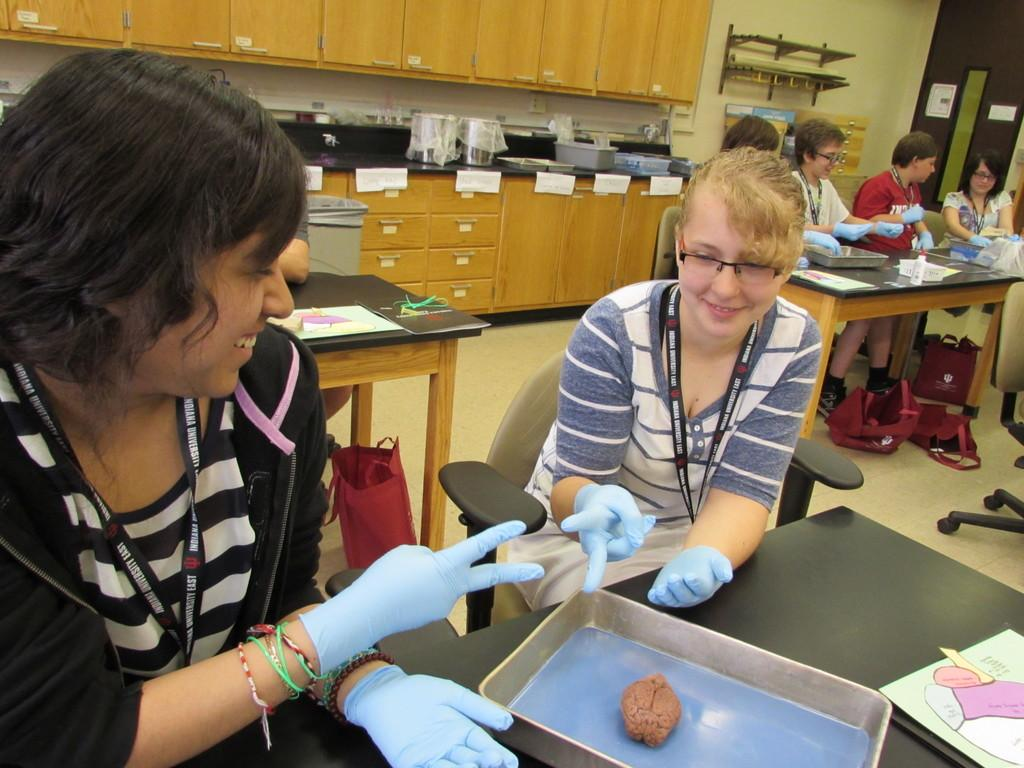How many women are in the image? There are two women in the image. What are the women doing in the image? The women are sitting in the image. What is in front of the women? There is a table in front of the women. Can you describe the people in the background of the image? There is another group of people in the background of the image, and they are also sitting. What type of powder is being used by the son in the image? There is no son present in the image, and therefore no such activity can be observed. 